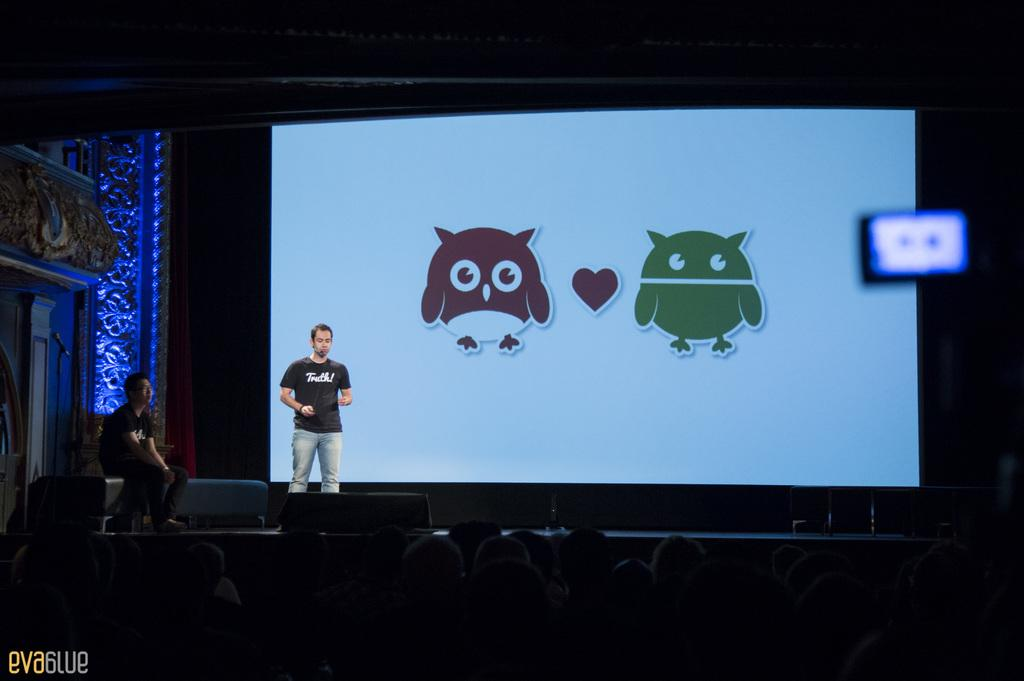What is happening at the bottom of the image? There are people standing at the bottom of the image. How are the people positioned in relation to each other? A person is standing in front of the standing people, and another person is sitting and watching in front of the standing people. What objects can be seen in the image? There is a screen and a microphone visible in the image. What type of bean is being discussed by the people in the image? There is no indication in the image that the people are discussing beans or any other specific topic. 